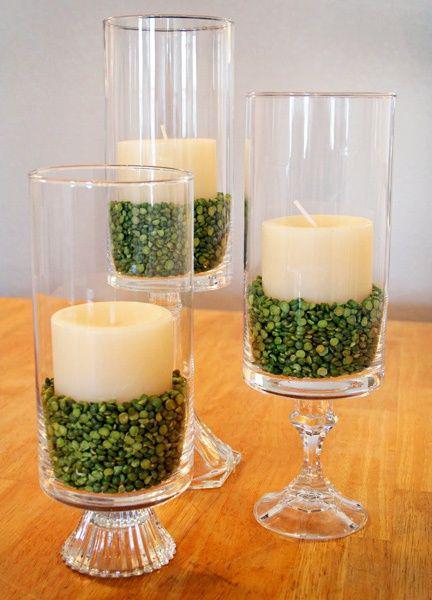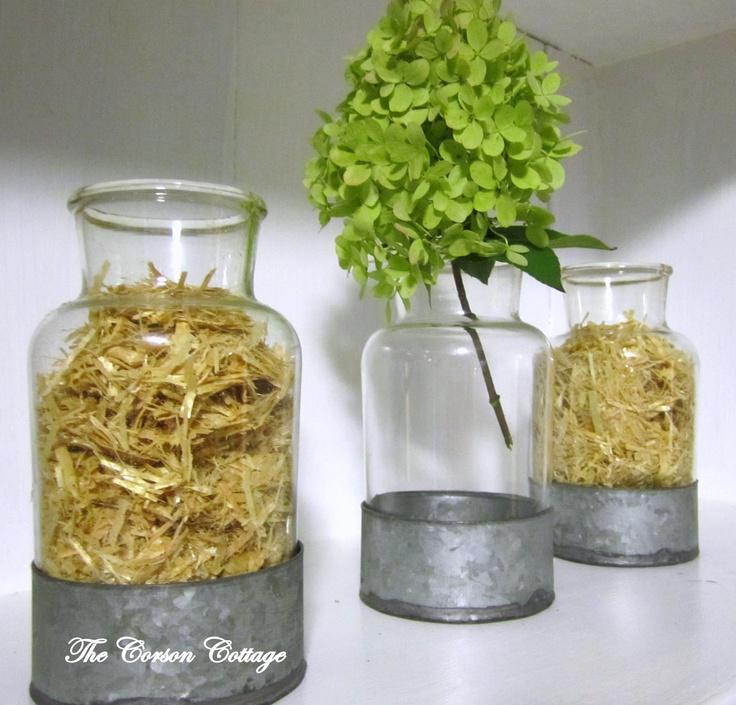The first image is the image on the left, the second image is the image on the right. Examine the images to the left and right. Is the description "The combined images include a clear container filled with lemons and one filled with apples." accurate? Answer yes or no. No. The first image is the image on the left, the second image is the image on the right. Evaluate the accuracy of this statement regarding the images: "All images show exactly three glass containers containing candles and/or greenery.". Is it true? Answer yes or no. Yes. 